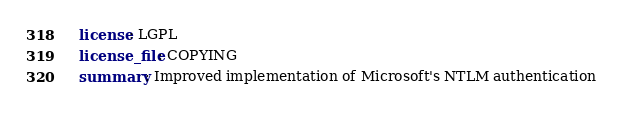Convert code to text. <code><loc_0><loc_0><loc_500><loc_500><_YAML_>  license: LGPL
  license_file: COPYING
  summary: Improved implementation of Microsoft's NTLM authentication
</code> 